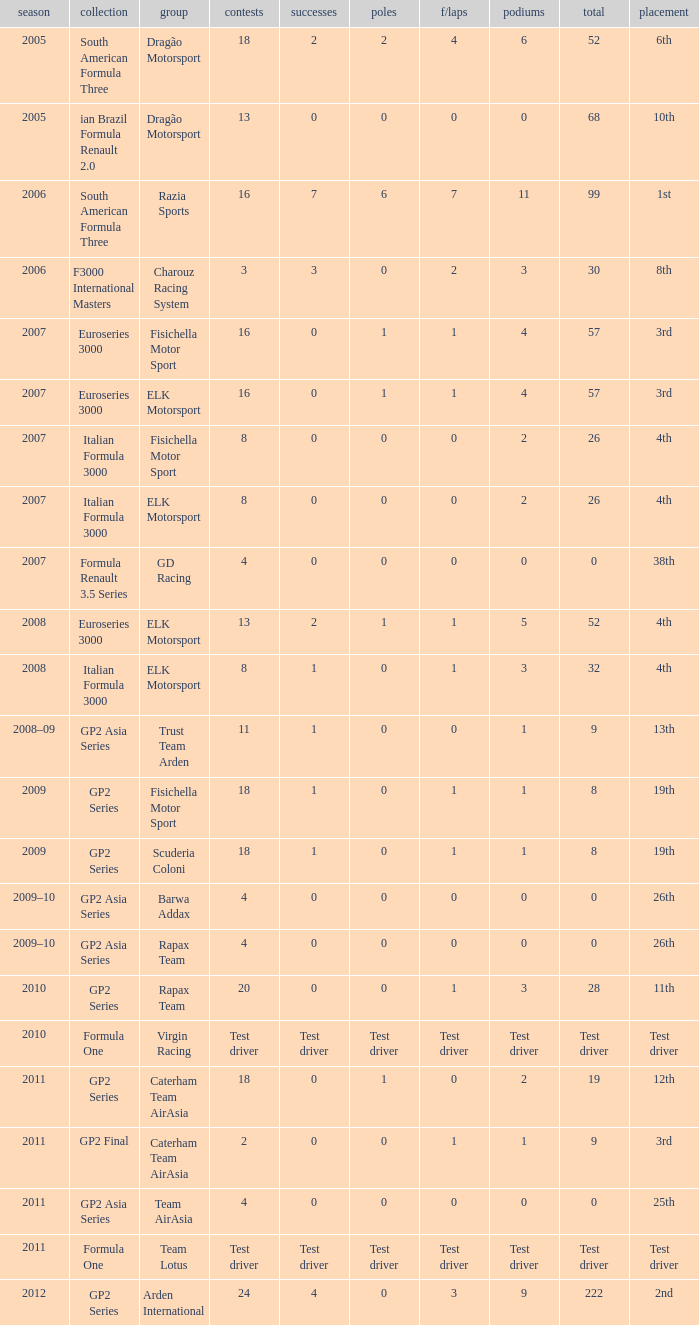How many races did he do in the year he had 8 points? 18, 18. 